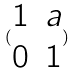Convert formula to latex. <formula><loc_0><loc_0><loc_500><loc_500>( \begin{matrix} 1 & a \\ 0 & 1 \end{matrix} )</formula> 